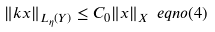<formula> <loc_0><loc_0><loc_500><loc_500>\| k x \| _ { L _ { \eta } ( Y ) } \leq C _ { 0 } \| x \| _ { X } \ e q n o ( 4 )</formula> 